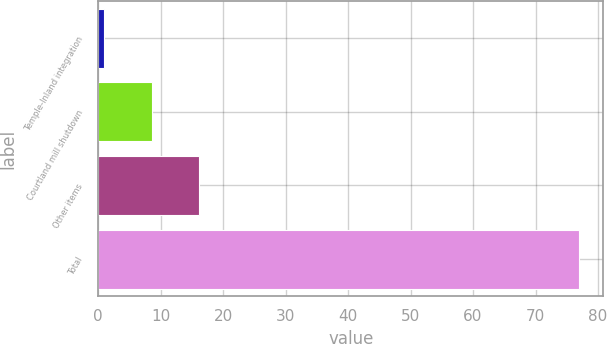Convert chart. <chart><loc_0><loc_0><loc_500><loc_500><bar_chart><fcel>Temple-Inland integration<fcel>Courtland mill shutdown<fcel>Other items<fcel>Total<nl><fcel>1<fcel>8.6<fcel>16.2<fcel>77<nl></chart> 